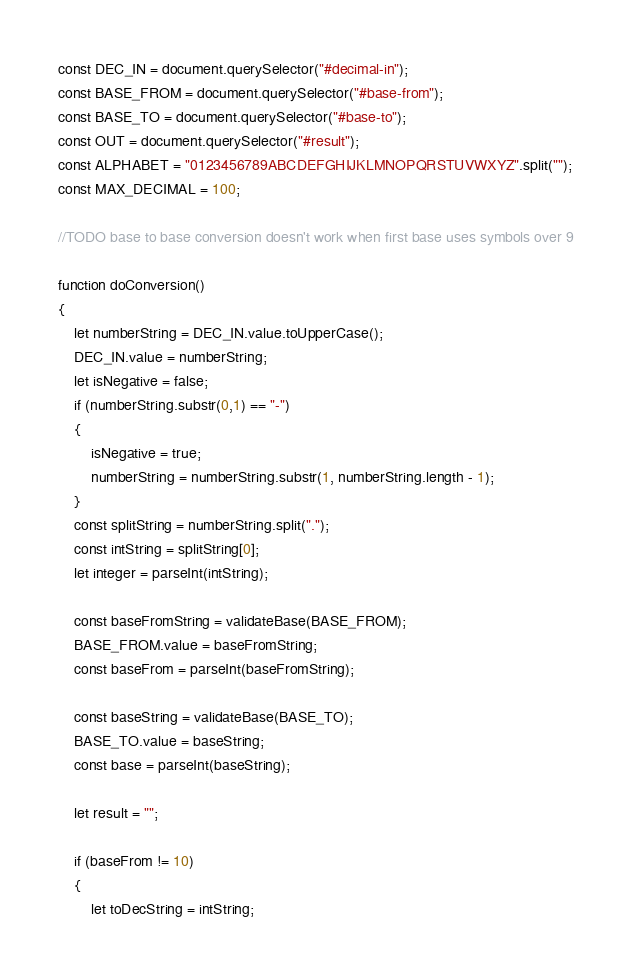Convert code to text. <code><loc_0><loc_0><loc_500><loc_500><_JavaScript_>const DEC_IN = document.querySelector("#decimal-in");
const BASE_FROM = document.querySelector("#base-from");
const BASE_TO = document.querySelector("#base-to");
const OUT = document.querySelector("#result");
const ALPHABET = "0123456789ABCDEFGHIJKLMNOPQRSTUVWXYZ".split("");
const MAX_DECIMAL = 100;

//TODO base to base conversion doesn't work when first base uses symbols over 9

function doConversion()
{
    let numberString = DEC_IN.value.toUpperCase();
    DEC_IN.value = numberString;
    let isNegative = false;
    if (numberString.substr(0,1) == "-")
    {
        isNegative = true;
        numberString = numberString.substr(1, numberString.length - 1);
    }
    const splitString = numberString.split(".");
    const intString = splitString[0];
    let integer = parseInt(intString);

    const baseFromString = validateBase(BASE_FROM);
    BASE_FROM.value = baseFromString;
    const baseFrom = parseInt(baseFromString);

    const baseString = validateBase(BASE_TO);
    BASE_TO.value = baseString;
    const base = parseInt(baseString);

    let result = "";

    if (baseFrom != 10)
    {
        let toDecString = intString;</code> 